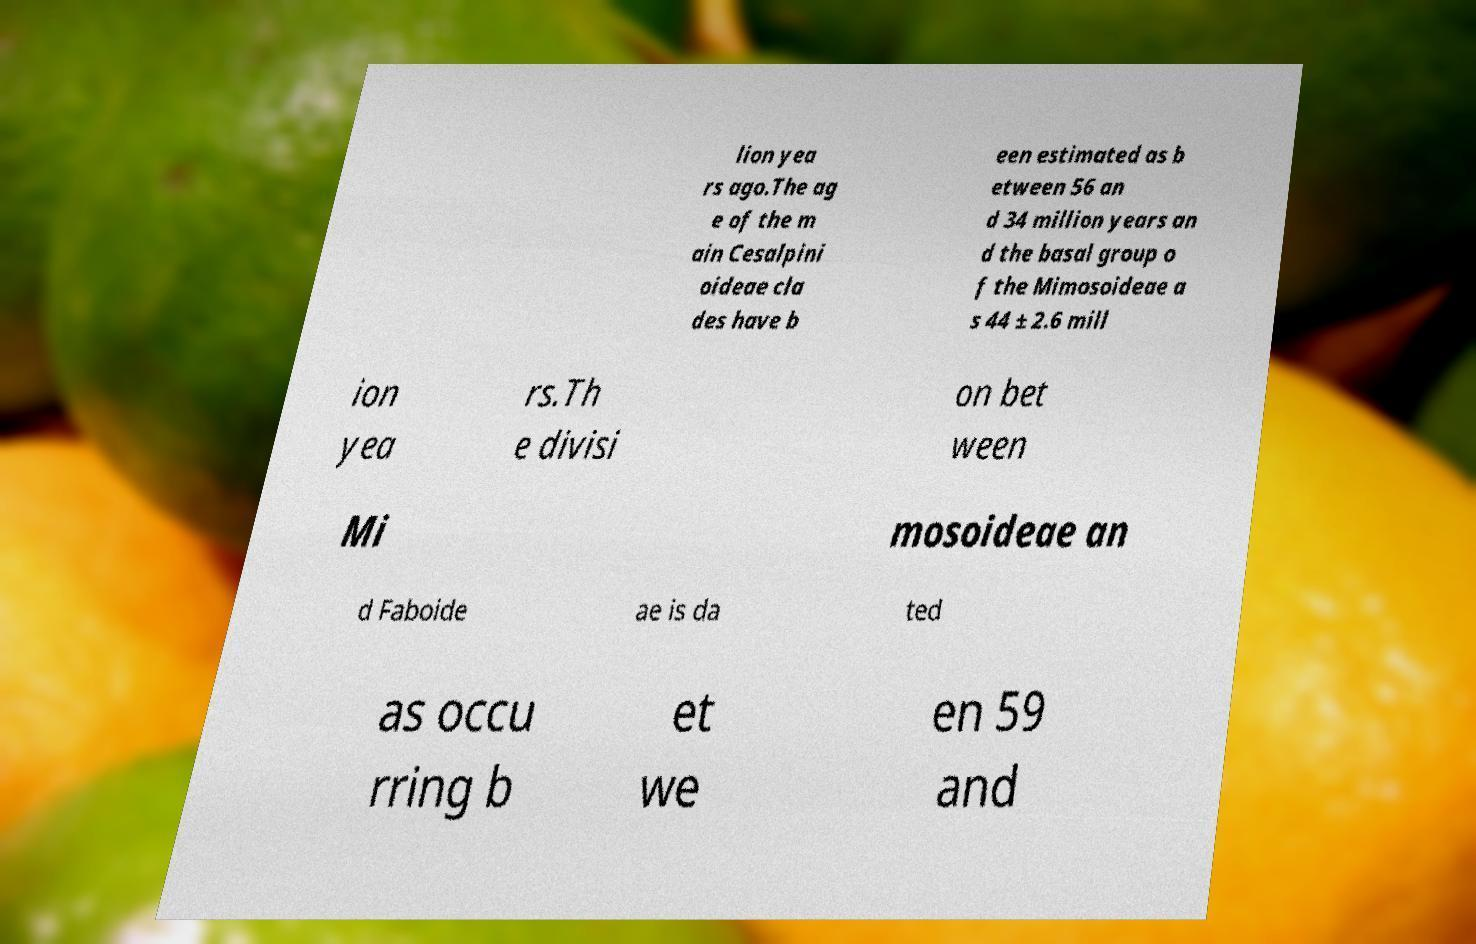Could you assist in decoding the text presented in this image and type it out clearly? lion yea rs ago.The ag e of the m ain Cesalpini oideae cla des have b een estimated as b etween 56 an d 34 million years an d the basal group o f the Mimosoideae a s 44 ± 2.6 mill ion yea rs.Th e divisi on bet ween Mi mosoideae an d Faboide ae is da ted as occu rring b et we en 59 and 